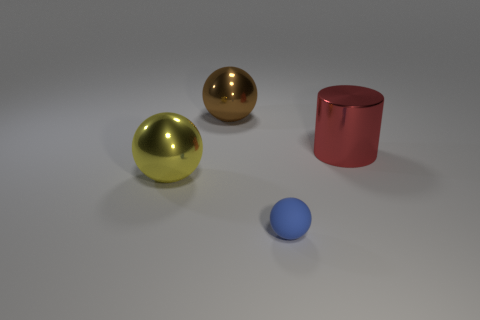Add 3 blue rubber balls. How many objects exist? 7 Subtract all spheres. How many objects are left? 1 Subtract 0 brown cylinders. How many objects are left? 4 Subtract all blue rubber balls. Subtract all big shiny spheres. How many objects are left? 1 Add 3 large brown metal things. How many large brown metal things are left? 4 Add 3 red shiny things. How many red shiny things exist? 4 